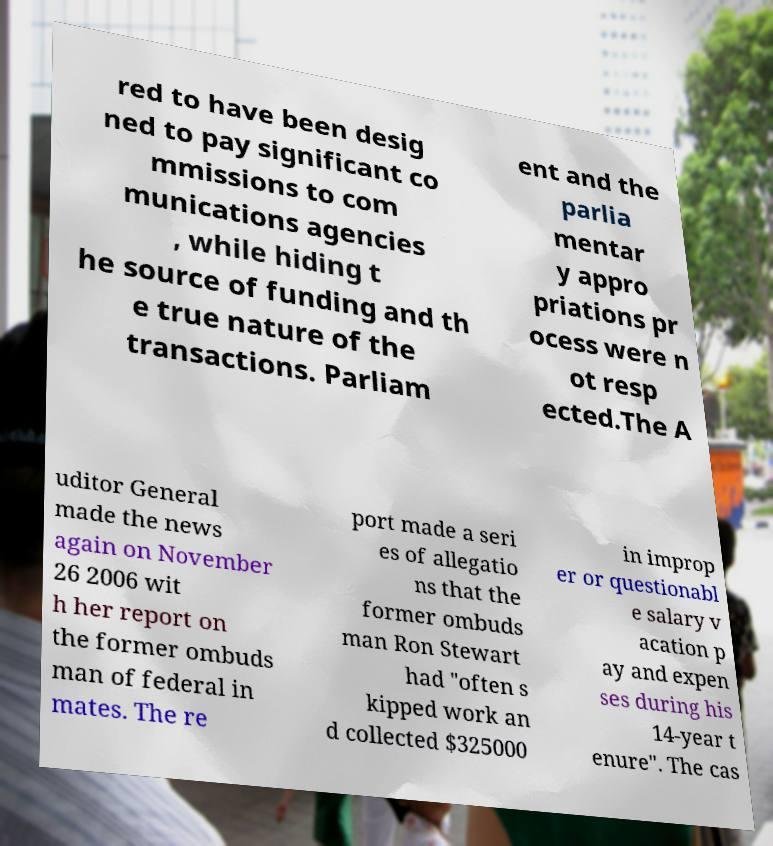Could you extract and type out the text from this image? red to have been desig ned to pay significant co mmissions to com munications agencies , while hiding t he source of funding and th e true nature of the transactions. Parliam ent and the parlia mentar y appro priations pr ocess were n ot resp ected.The A uditor General made the news again on November 26 2006 wit h her report on the former ombuds man of federal in mates. The re port made a seri es of allegatio ns that the former ombuds man Ron Stewart had "often s kipped work an d collected $325000 in improp er or questionabl e salary v acation p ay and expen ses during his 14-year t enure". The cas 